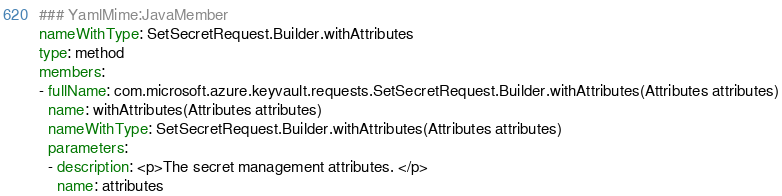<code> <loc_0><loc_0><loc_500><loc_500><_YAML_>### YamlMime:JavaMember
nameWithType: SetSecretRequest.Builder.withAttributes
type: method
members:
- fullName: com.microsoft.azure.keyvault.requests.SetSecretRequest.Builder.withAttributes(Attributes attributes)
  name: withAttributes(Attributes attributes)
  nameWithType: SetSecretRequest.Builder.withAttributes(Attributes attributes)
  parameters:
  - description: <p>The secret management attributes. </p>
    name: attributes</code> 